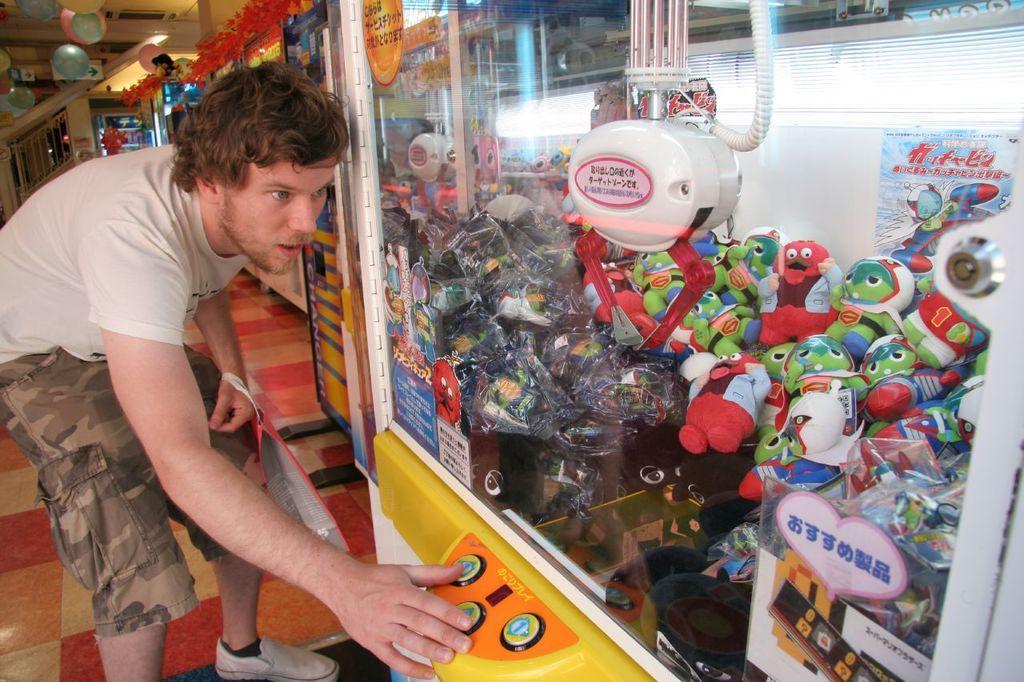Describe this image in one or two sentences. In this image we can see a person holding a bag. Also there is a box with buttons. Inside the box there are many dolls. On the ceiling there are balloons. In the back there are some decorations. 